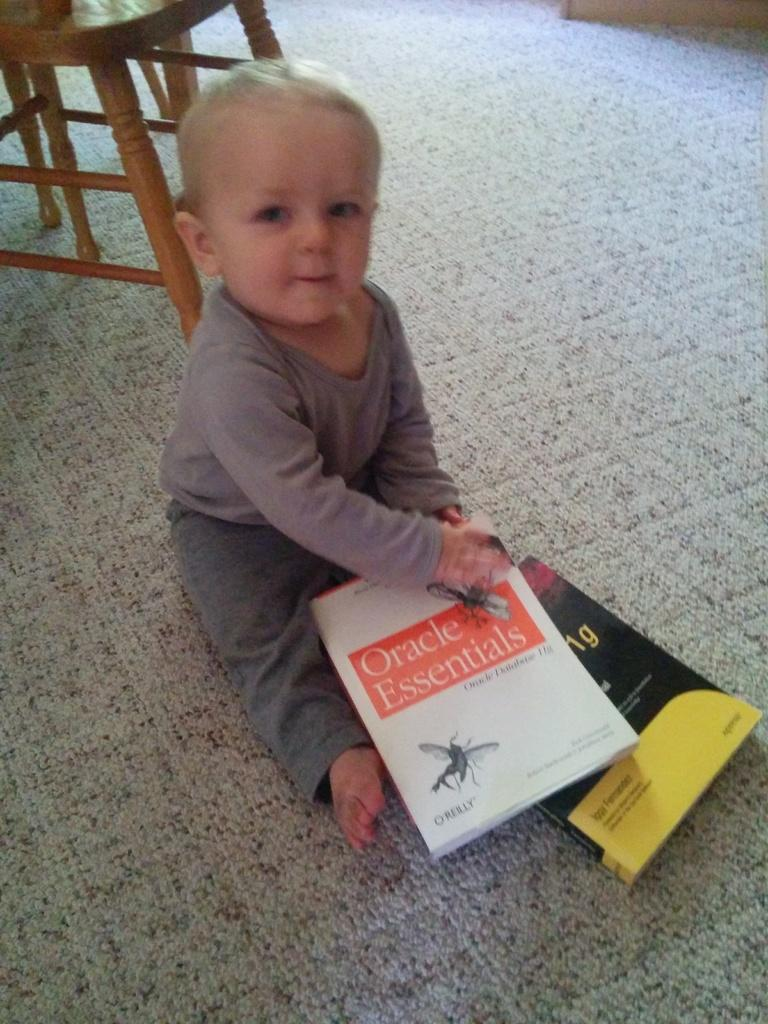What is the baby doing in the image? The baby is sitting on the carpet in the image. What objects are near the baby? There are books near the baby. What can be seen in the background of the image? There is a table in the background of the image. Can you see a river flowing near the baby in the image? No, there is no river visible in the image. 